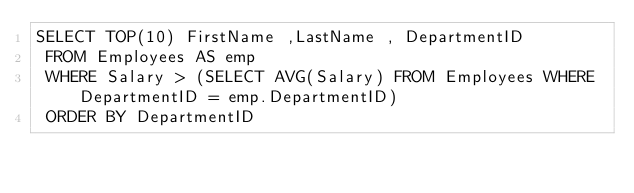Convert code to text. <code><loc_0><loc_0><loc_500><loc_500><_SQL_>SELECT TOP(10) FirstName ,LastName , DepartmentID 
 FROM Employees AS emp
 WHERE Salary > (SELECT AVG(Salary) FROM Employees WHERE DepartmentID = emp.DepartmentID)
 ORDER BY DepartmentID</code> 